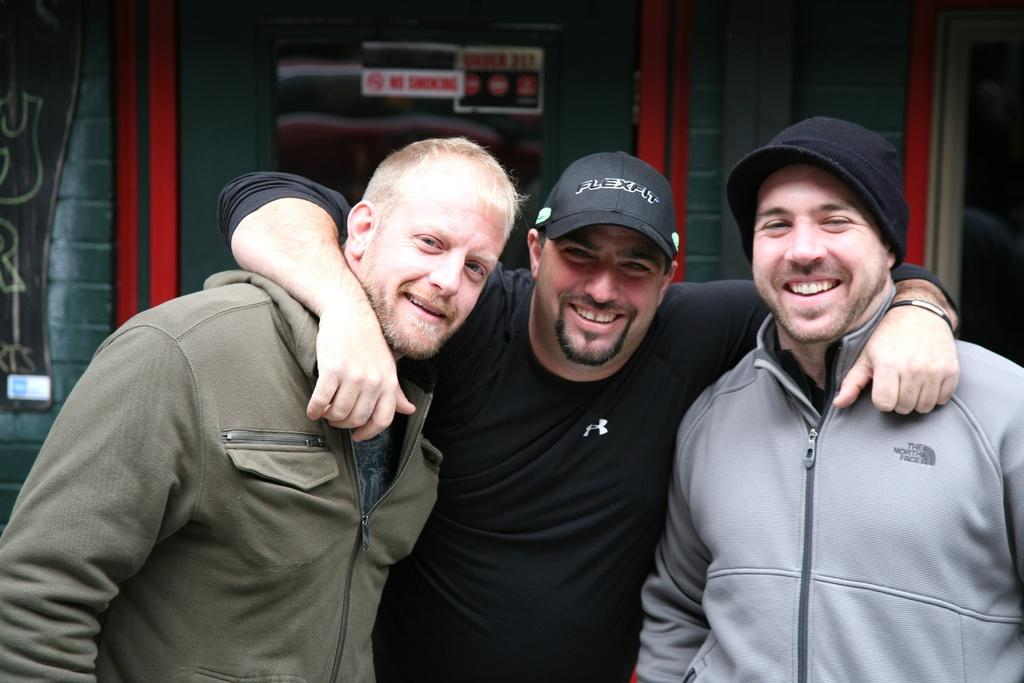How many people are in the image? There are three people in the image. What are the people doing in the image? The people are standing and smiling. What can be seen in the background of the image? There is a building and boards visible in the background of the image. What type of bomb can be seen in the image? There is no bomb present in the image. Can you tell me how many fangs are visible on the people in the image? The people in the image do not have fangs, as they are not animals. 